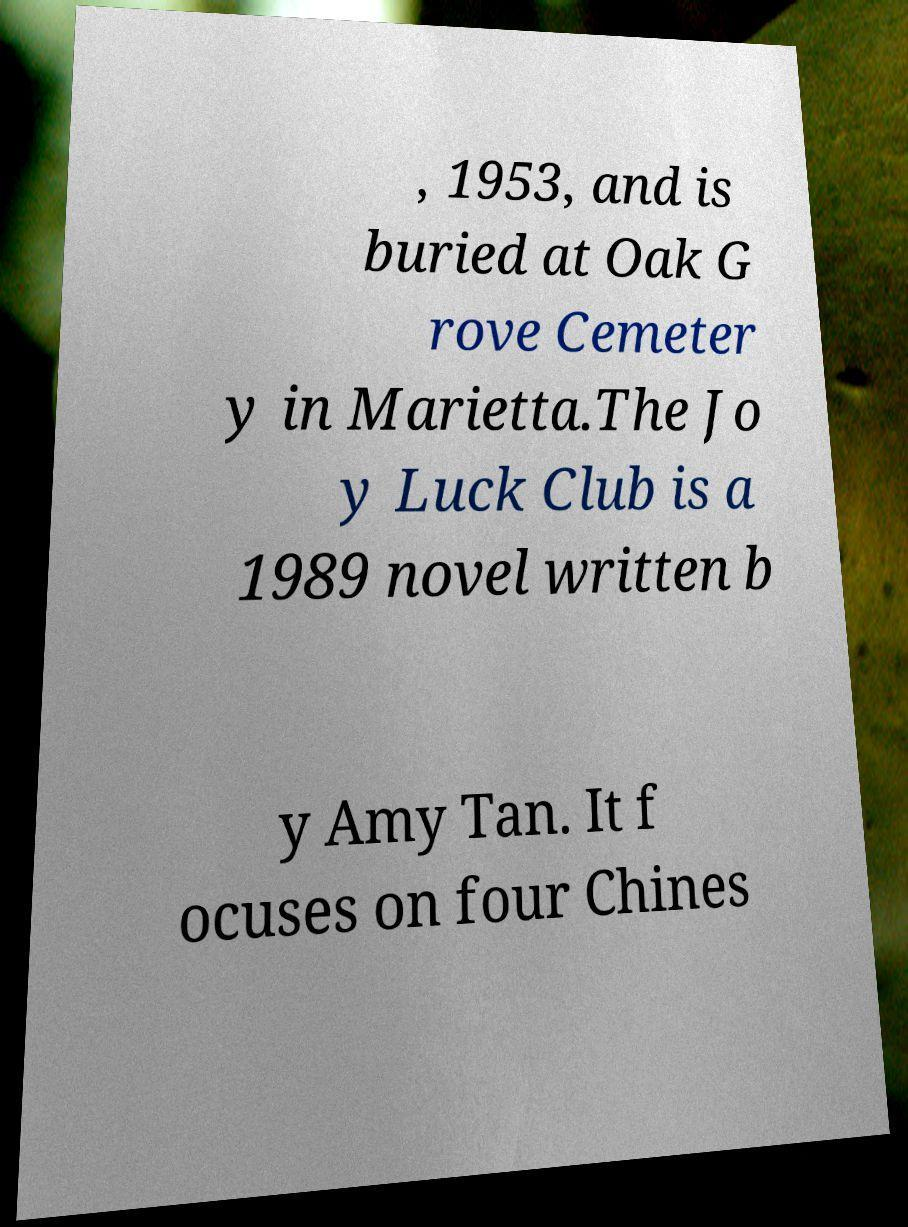For documentation purposes, I need the text within this image transcribed. Could you provide that? , 1953, and is buried at Oak G rove Cemeter y in Marietta.The Jo y Luck Club is a 1989 novel written b y Amy Tan. It f ocuses on four Chines 